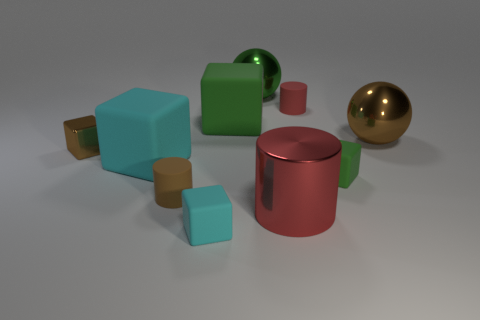What number of tiny rubber cylinders have the same color as the big metallic cylinder?
Ensure brevity in your answer.  1. Does the shiny cube have the same color as the tiny rubber cylinder that is on the left side of the red rubber object?
Offer a very short reply. Yes. There is another cylinder that is the same color as the metal cylinder; what is its material?
Give a very brief answer. Rubber. Is there anything else that is the same shape as the tiny brown metallic object?
Make the answer very short. Yes. The red thing that is on the right side of the large thing that is in front of the matte cylinder that is on the left side of the tiny cyan rubber object is what shape?
Ensure brevity in your answer.  Cylinder. There is a small brown rubber thing; what shape is it?
Your answer should be very brief. Cylinder. What color is the tiny matte block on the right side of the metal cylinder?
Your answer should be very brief. Green. There is a red cylinder in front of the red rubber cylinder; is its size the same as the large brown metallic thing?
Provide a short and direct response. Yes. The brown object that is the same shape as the tiny green thing is what size?
Provide a short and direct response. Small. Are there any other things that are the same size as the brown cylinder?
Your answer should be very brief. Yes. 